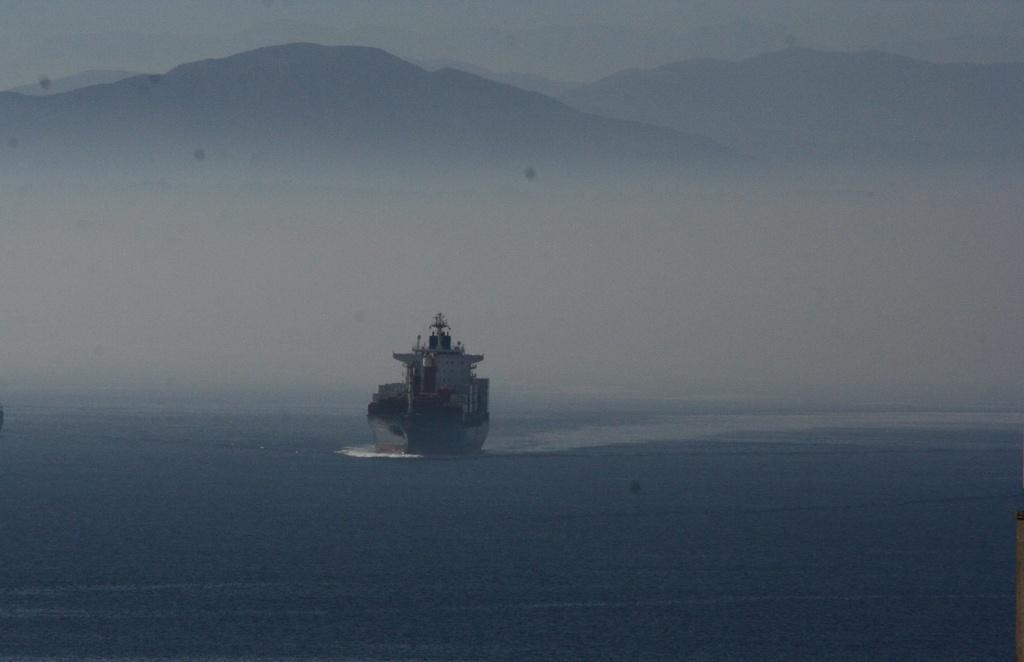Can you describe this image briefly? In this image a ship is sailing on the ocean. There are many hills at the top of the image. 